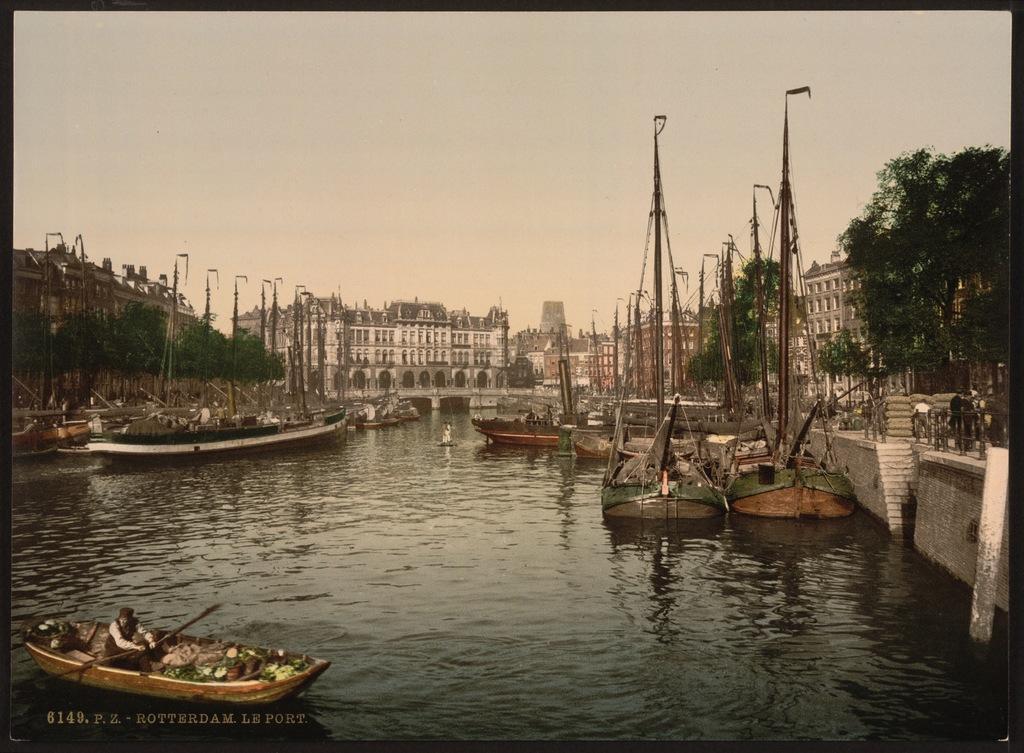Describe this image in one or two sentences. In this picture I can see boats on the water, there are group of people, buildings, trees, and in the background there is sky and a watermark on the image. 